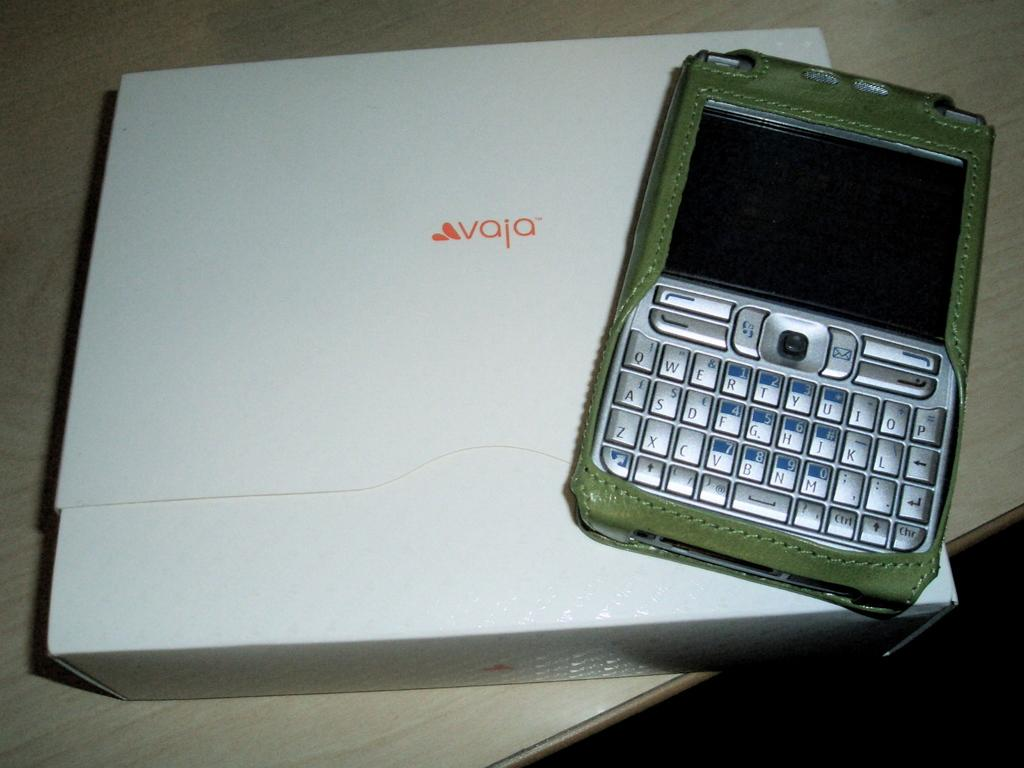Provide a one-sentence caption for the provided image. a smart phone from vaja with a qwerty keyboard. 